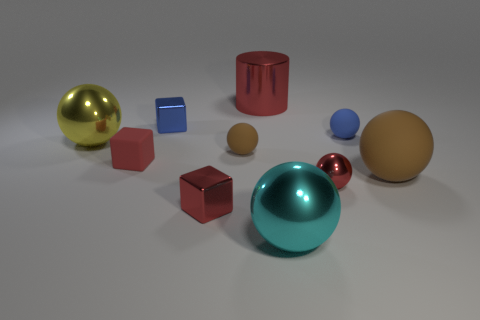Is there anything else that has the same shape as the small blue rubber thing?
Your response must be concise. Yes. Is there a cylinder that has the same color as the large rubber ball?
Ensure brevity in your answer.  No. Do the small object that is behind the blue matte sphere and the tiny brown sphere right of the yellow shiny sphere have the same material?
Offer a very short reply. No. The large cylinder has what color?
Your answer should be compact. Red. How big is the red metal object behind the brown rubber object on the right side of the metal ball in front of the small shiny sphere?
Keep it short and to the point. Large. How many other objects are the same size as the cylinder?
Offer a very short reply. 3. What number of cyan balls are made of the same material as the small brown thing?
Your response must be concise. 0. The red object on the right side of the large red thing has what shape?
Your answer should be compact. Sphere. Are the cylinder and the large cyan ball that is to the right of the tiny blue shiny block made of the same material?
Your answer should be very brief. Yes. Is there a small cyan object?
Offer a very short reply. No. 